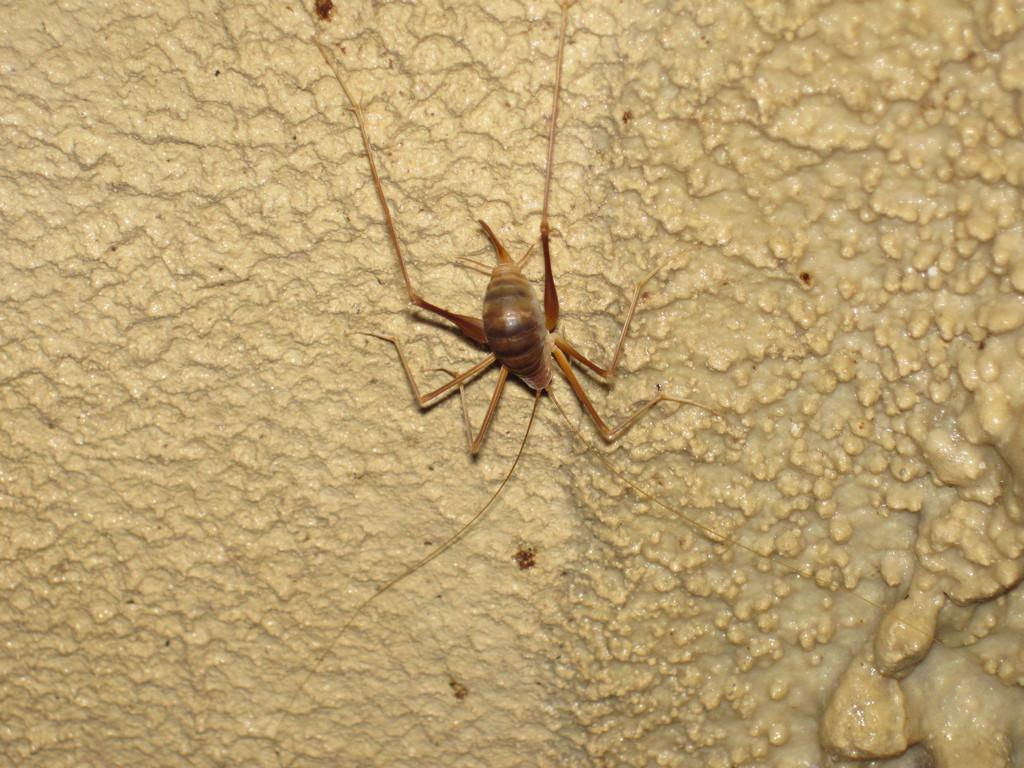What type of creature can be seen in the image? There is an insect in the image. What is the insect doing in the image? The insect is moving around on a surface. What color is the grape that the insect is holding in the image? There is no grape present in the image, and the insect is not holding anything. 